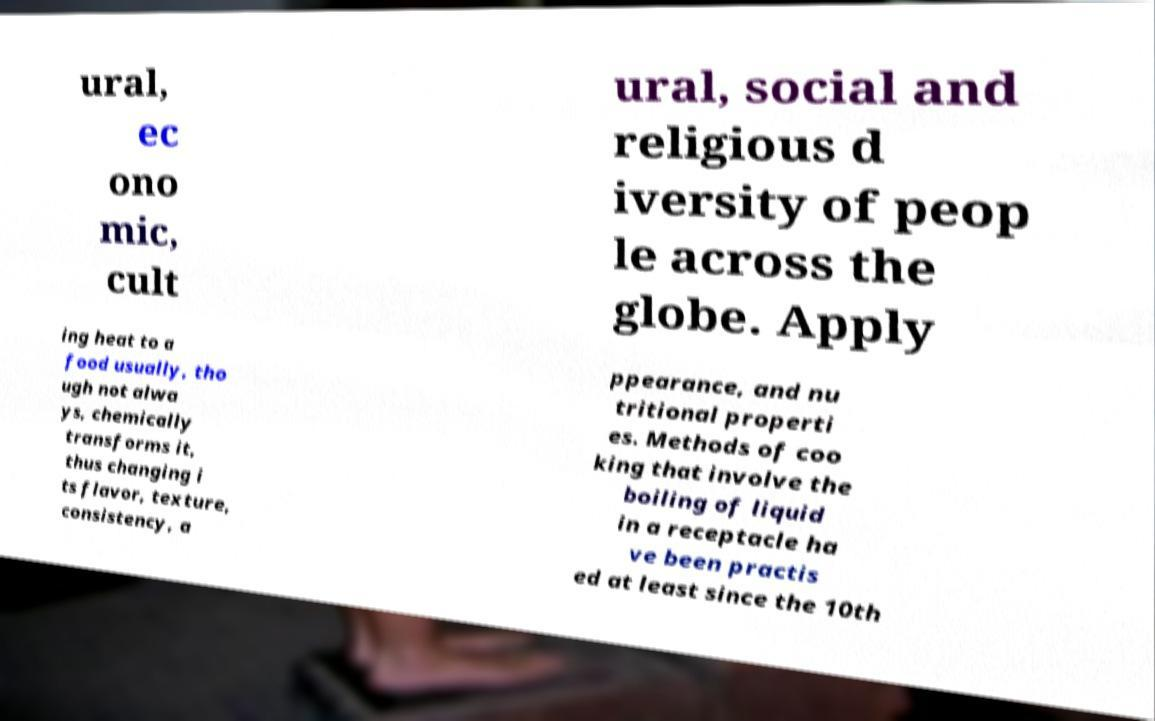Can you read and provide the text displayed in the image?This photo seems to have some interesting text. Can you extract and type it out for me? ural, ec ono mic, cult ural, social and religious d iversity of peop le across the globe. Apply ing heat to a food usually, tho ugh not alwa ys, chemically transforms it, thus changing i ts flavor, texture, consistency, a ppearance, and nu tritional properti es. Methods of coo king that involve the boiling of liquid in a receptacle ha ve been practis ed at least since the 10th 